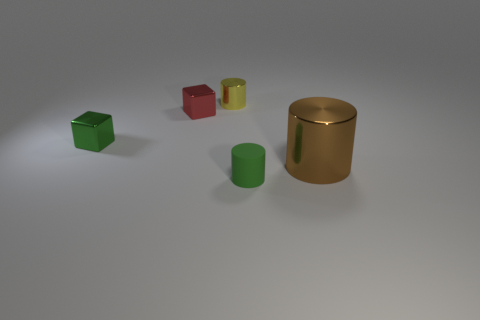Is there a small purple cube made of the same material as the large cylinder?
Your answer should be very brief. No. Is there anything else that is the same material as the tiny green cylinder?
Your answer should be very brief. No. The large cylinder has what color?
Give a very brief answer. Brown. The shiny block that is the same size as the red metal object is what color?
Offer a terse response. Green. What number of rubber things are either large cylinders or small red cylinders?
Your answer should be very brief. 0. What number of objects are in front of the small red thing and left of the yellow thing?
Provide a succinct answer. 1. Are there any other things that are the same shape as the tiny yellow thing?
Provide a short and direct response. Yes. How many other objects are there of the same size as the brown cylinder?
Provide a succinct answer. 0. There is a thing to the right of the small green rubber cylinder; does it have the same size as the shiny cube that is left of the red object?
Provide a short and direct response. No. How many objects are small metallic cubes or shiny things that are behind the red thing?
Your answer should be compact. 3. 